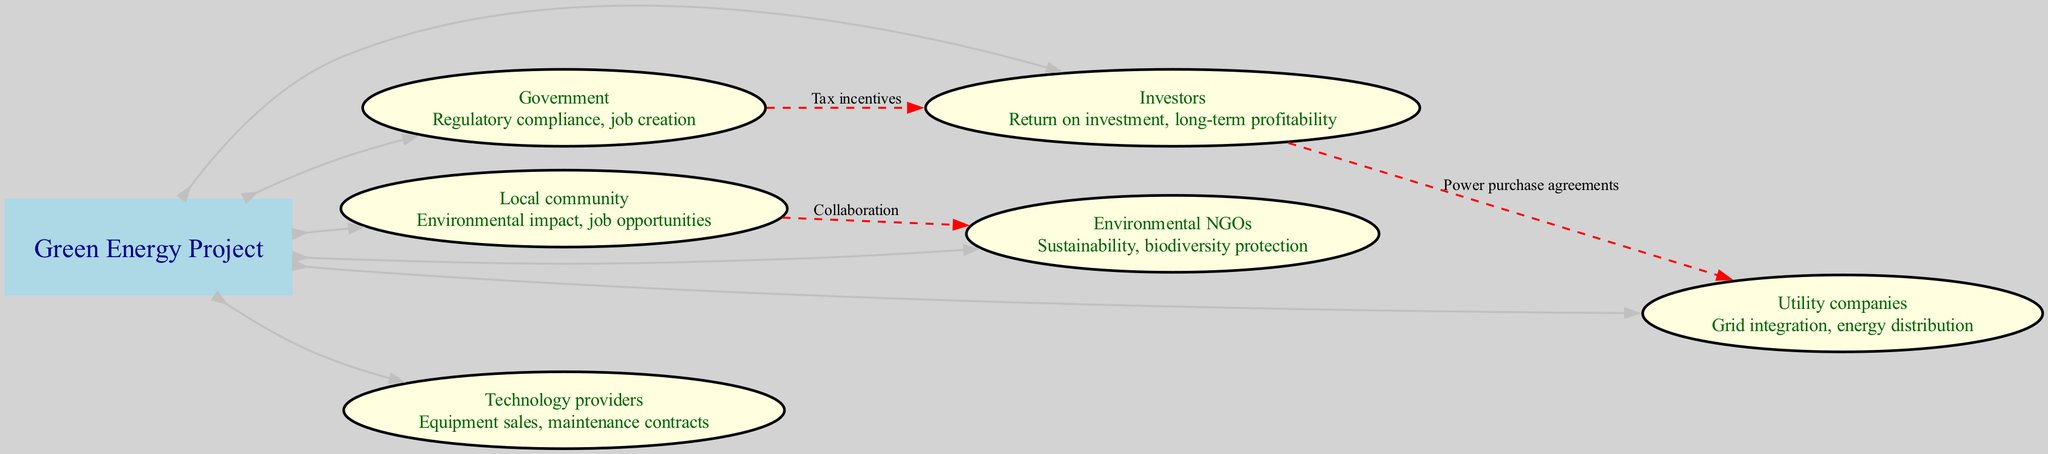What is the central topic of the diagram? The diagram highlights a central topic labeled "Green Energy Project." This can be clearly identified at the center of the diagram surrounded by various stakeholders.
Answer: Green Energy Project How many stakeholders are represented in the diagram? By counting the distinct entities that represent interests in the project, we see six stakeholders listed: Government, Local community, Investors, Environmental NGOs, Utility companies, and Technology providers.
Answer: 6 What interest does the Local community have? The Local community's interest is explicitly stated in the diagram as "Environmental impact, job opportunities," making it clear what they are focused on in relation to the project.
Answer: Environmental impact, job opportunities Which stakeholder is associated with tax incentives? The diagram indicates that the connection labeled "Tax incentives" arises from the Government and points towards Investors, indicating the Government's role in providing incentives to investors.
Answer: Government What type of connection exists between Local community and Environmental NGOs? The diagram illustrates a connection labeled "Collaboration," indicating that the Local community and Environmental NGOs work together towards common goals related to the green energy project.
Answer: Collaboration Which stakeholders are linked by power purchase agreements? According to the connections depicted in the diagram, Investors and Utility companies are linked by "Power purchase agreements," showing a financial relationship centered around energy distribution.
Answer: Investors, Utility companies What is the interest of Environmental NGOs? The interest of Environmental NGOs is stated clearly in the diagram as "Sustainability, biodiversity protection," emphasizing their focus on ecological preservation in the context of the green energy project.
Answer: Sustainability, biodiversity protection Which two stakeholders are connected by dashed lines in the diagram? The dashed lines in the diagram represent connections, specifically between the Government and Investors (Tax incentives), Local community and Environmental NGOs (Collaboration), and Investors and Utility companies (Power purchase agreements). All these pairs show key relationships in the project.
Answer: Government- Investors, Local community- Environmental NGOs, Investors- Utility companies What color are the stakeholder nodes in the diagram? The stakeholder nodes, which are represented as ellipses, are filled with light yellow color in the diagram to distinguish them from the central topic and highlight their interests.
Answer: light yellow 